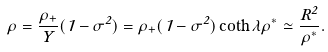Convert formula to latex. <formula><loc_0><loc_0><loc_500><loc_500>\rho = { \frac { \rho _ { + } } { Y } } ( 1 - \sigma ^ { 2 } ) = \rho _ { + } ( 1 - \sigma ^ { 2 } ) \coth \lambda \rho ^ { * } \simeq { \frac { R ^ { 2 } } { \rho ^ { * } } } .</formula> 